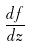<formula> <loc_0><loc_0><loc_500><loc_500>\frac { d f } { d z }</formula> 